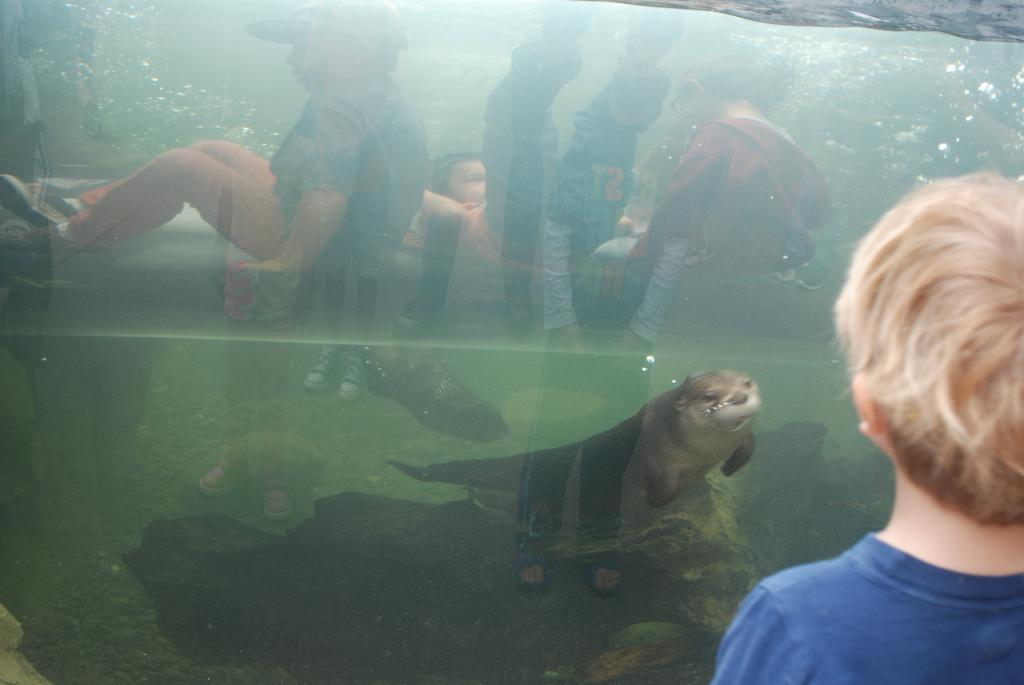How would you summarize this image in a sentence or two? On the right side of this image there is a person facing towards the back side. In front of this person there is a fish tank. Inside I can see the water and a fish. On the glass, I can see the reflection of some people. 